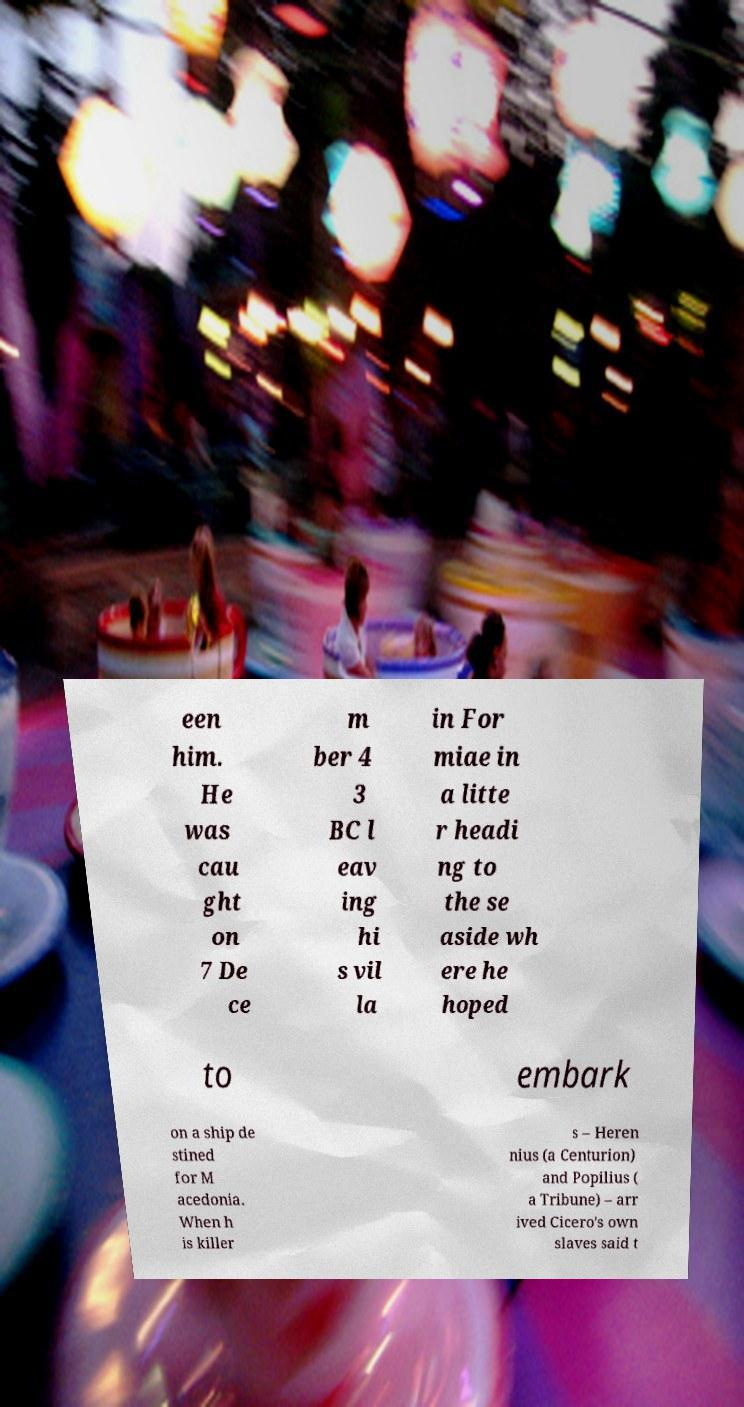For documentation purposes, I need the text within this image transcribed. Could you provide that? een him. He was cau ght on 7 De ce m ber 4 3 BC l eav ing hi s vil la in For miae in a litte r headi ng to the se aside wh ere he hoped to embark on a ship de stined for M acedonia. When h is killer s – Heren nius (a Centurion) and Popilius ( a Tribune) – arr ived Cicero's own slaves said t 